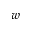Convert formula to latex. <formula><loc_0><loc_0><loc_500><loc_500>w</formula> 